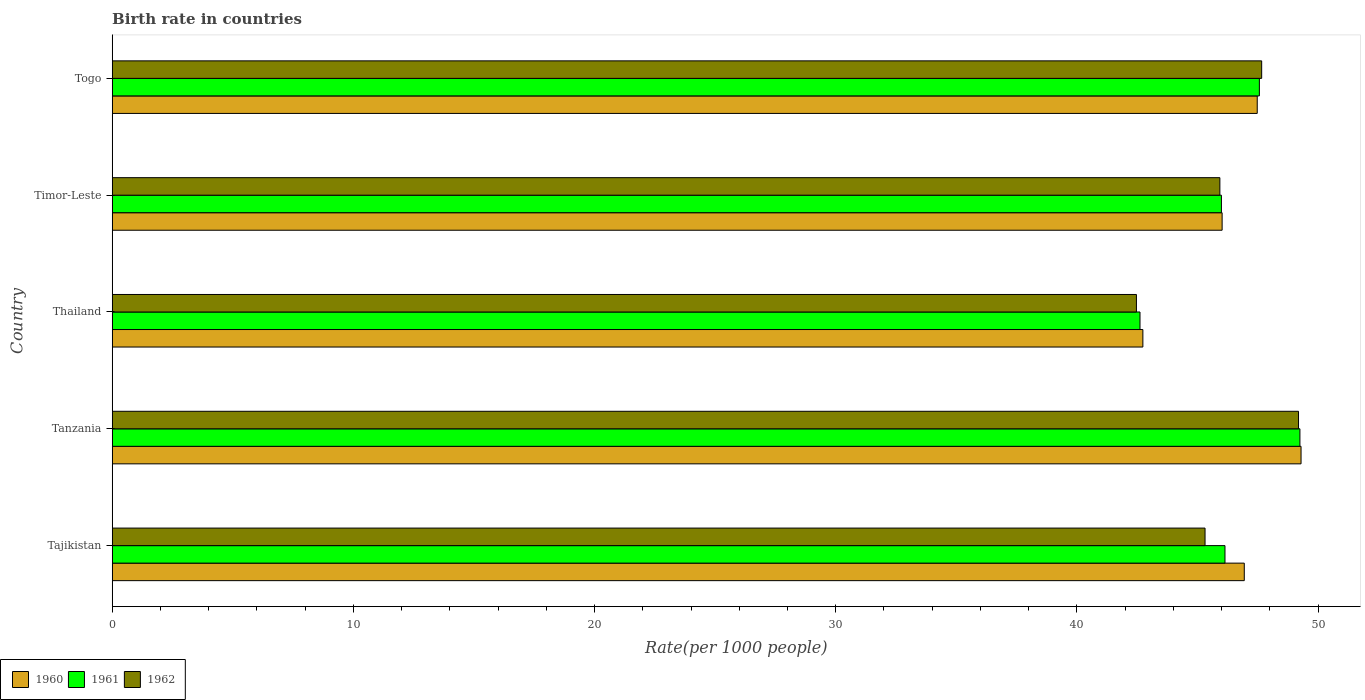How many different coloured bars are there?
Your response must be concise. 3. How many groups of bars are there?
Give a very brief answer. 5. How many bars are there on the 5th tick from the bottom?
Your response must be concise. 3. What is the label of the 1st group of bars from the top?
Offer a terse response. Togo. In how many cases, is the number of bars for a given country not equal to the number of legend labels?
Offer a very short reply. 0. What is the birth rate in 1961 in Timor-Leste?
Offer a very short reply. 45.99. Across all countries, what is the maximum birth rate in 1960?
Provide a succinct answer. 49.3. Across all countries, what is the minimum birth rate in 1961?
Provide a short and direct response. 42.62. In which country was the birth rate in 1961 maximum?
Ensure brevity in your answer.  Tanzania. In which country was the birth rate in 1960 minimum?
Your answer should be very brief. Thailand. What is the total birth rate in 1961 in the graph?
Your response must be concise. 231.57. What is the difference between the birth rate in 1960 in Tajikistan and that in Timor-Leste?
Your response must be concise. 0.92. What is the difference between the birth rate in 1962 in Togo and the birth rate in 1961 in Tanzania?
Offer a very short reply. -1.59. What is the average birth rate in 1961 per country?
Provide a short and direct response. 46.31. What is the difference between the birth rate in 1960 and birth rate in 1961 in Tajikistan?
Your answer should be compact. 0.8. What is the ratio of the birth rate in 1960 in Timor-Leste to that in Togo?
Make the answer very short. 0.97. What is the difference between the highest and the second highest birth rate in 1962?
Provide a short and direct response. 1.53. What is the difference between the highest and the lowest birth rate in 1961?
Your answer should be compact. 6.63. In how many countries, is the birth rate in 1961 greater than the average birth rate in 1961 taken over all countries?
Make the answer very short. 2. Is the sum of the birth rate in 1962 in Tajikistan and Thailand greater than the maximum birth rate in 1960 across all countries?
Ensure brevity in your answer.  Yes. What does the 2nd bar from the bottom in Tajikistan represents?
Your response must be concise. 1961. Is it the case that in every country, the sum of the birth rate in 1962 and birth rate in 1960 is greater than the birth rate in 1961?
Offer a very short reply. Yes. Are all the bars in the graph horizontal?
Offer a very short reply. Yes. How many countries are there in the graph?
Offer a very short reply. 5. Are the values on the major ticks of X-axis written in scientific E-notation?
Your answer should be compact. No. Does the graph contain any zero values?
Give a very brief answer. No. Does the graph contain grids?
Ensure brevity in your answer.  No. Where does the legend appear in the graph?
Ensure brevity in your answer.  Bottom left. What is the title of the graph?
Your response must be concise. Birth rate in countries. Does "1974" appear as one of the legend labels in the graph?
Make the answer very short. No. What is the label or title of the X-axis?
Make the answer very short. Rate(per 1000 people). What is the Rate(per 1000 people) of 1960 in Tajikistan?
Keep it short and to the point. 46.94. What is the Rate(per 1000 people) of 1961 in Tajikistan?
Ensure brevity in your answer.  46.14. What is the Rate(per 1000 people) of 1962 in Tajikistan?
Your answer should be very brief. 45.31. What is the Rate(per 1000 people) of 1960 in Tanzania?
Ensure brevity in your answer.  49.3. What is the Rate(per 1000 people) of 1961 in Tanzania?
Your answer should be very brief. 49.25. What is the Rate(per 1000 people) of 1962 in Tanzania?
Offer a terse response. 49.19. What is the Rate(per 1000 people) in 1960 in Thailand?
Offer a terse response. 42.74. What is the Rate(per 1000 people) in 1961 in Thailand?
Keep it short and to the point. 42.62. What is the Rate(per 1000 people) of 1962 in Thailand?
Your response must be concise. 42.47. What is the Rate(per 1000 people) of 1960 in Timor-Leste?
Your response must be concise. 46.02. What is the Rate(per 1000 people) of 1961 in Timor-Leste?
Your answer should be very brief. 45.99. What is the Rate(per 1000 people) of 1962 in Timor-Leste?
Your answer should be very brief. 45.93. What is the Rate(per 1000 people) in 1960 in Togo?
Offer a very short reply. 47.48. What is the Rate(per 1000 people) in 1961 in Togo?
Your answer should be very brief. 47.57. What is the Rate(per 1000 people) in 1962 in Togo?
Your answer should be compact. 47.66. Across all countries, what is the maximum Rate(per 1000 people) of 1960?
Give a very brief answer. 49.3. Across all countries, what is the maximum Rate(per 1000 people) of 1961?
Keep it short and to the point. 49.25. Across all countries, what is the maximum Rate(per 1000 people) in 1962?
Provide a short and direct response. 49.19. Across all countries, what is the minimum Rate(per 1000 people) in 1960?
Your response must be concise. 42.74. Across all countries, what is the minimum Rate(per 1000 people) in 1961?
Your answer should be compact. 42.62. Across all countries, what is the minimum Rate(per 1000 people) of 1962?
Your answer should be very brief. 42.47. What is the total Rate(per 1000 people) of 1960 in the graph?
Provide a succinct answer. 232.48. What is the total Rate(per 1000 people) in 1961 in the graph?
Your answer should be very brief. 231.57. What is the total Rate(per 1000 people) in 1962 in the graph?
Offer a terse response. 230.57. What is the difference between the Rate(per 1000 people) in 1960 in Tajikistan and that in Tanzania?
Ensure brevity in your answer.  -2.35. What is the difference between the Rate(per 1000 people) in 1961 in Tajikistan and that in Tanzania?
Provide a short and direct response. -3.11. What is the difference between the Rate(per 1000 people) in 1962 in Tajikistan and that in Tanzania?
Offer a very short reply. -3.88. What is the difference between the Rate(per 1000 people) of 1960 in Tajikistan and that in Thailand?
Offer a terse response. 4.21. What is the difference between the Rate(per 1000 people) of 1961 in Tajikistan and that in Thailand?
Ensure brevity in your answer.  3.52. What is the difference between the Rate(per 1000 people) of 1962 in Tajikistan and that in Thailand?
Keep it short and to the point. 2.85. What is the difference between the Rate(per 1000 people) in 1960 in Tajikistan and that in Timor-Leste?
Your answer should be very brief. 0.92. What is the difference between the Rate(per 1000 people) of 1961 in Tajikistan and that in Timor-Leste?
Make the answer very short. 0.15. What is the difference between the Rate(per 1000 people) in 1962 in Tajikistan and that in Timor-Leste?
Provide a succinct answer. -0.61. What is the difference between the Rate(per 1000 people) of 1960 in Tajikistan and that in Togo?
Your response must be concise. -0.54. What is the difference between the Rate(per 1000 people) in 1961 in Tajikistan and that in Togo?
Your answer should be compact. -1.43. What is the difference between the Rate(per 1000 people) of 1962 in Tajikistan and that in Togo?
Provide a short and direct response. -2.35. What is the difference between the Rate(per 1000 people) of 1960 in Tanzania and that in Thailand?
Offer a terse response. 6.56. What is the difference between the Rate(per 1000 people) of 1961 in Tanzania and that in Thailand?
Provide a succinct answer. 6.63. What is the difference between the Rate(per 1000 people) in 1962 in Tanzania and that in Thailand?
Make the answer very short. 6.72. What is the difference between the Rate(per 1000 people) of 1960 in Tanzania and that in Timor-Leste?
Offer a terse response. 3.27. What is the difference between the Rate(per 1000 people) of 1961 in Tanzania and that in Timor-Leste?
Provide a succinct answer. 3.25. What is the difference between the Rate(per 1000 people) in 1962 in Tanzania and that in Timor-Leste?
Offer a terse response. 3.26. What is the difference between the Rate(per 1000 people) in 1960 in Tanzania and that in Togo?
Make the answer very short. 1.82. What is the difference between the Rate(per 1000 people) of 1961 in Tanzania and that in Togo?
Offer a terse response. 1.68. What is the difference between the Rate(per 1000 people) of 1962 in Tanzania and that in Togo?
Your response must be concise. 1.53. What is the difference between the Rate(per 1000 people) of 1960 in Thailand and that in Timor-Leste?
Provide a short and direct response. -3.29. What is the difference between the Rate(per 1000 people) in 1961 in Thailand and that in Timor-Leste?
Provide a short and direct response. -3.38. What is the difference between the Rate(per 1000 people) in 1962 in Thailand and that in Timor-Leste?
Your response must be concise. -3.46. What is the difference between the Rate(per 1000 people) in 1960 in Thailand and that in Togo?
Provide a short and direct response. -4.74. What is the difference between the Rate(per 1000 people) of 1961 in Thailand and that in Togo?
Your response must be concise. -4.95. What is the difference between the Rate(per 1000 people) of 1962 in Thailand and that in Togo?
Provide a short and direct response. -5.19. What is the difference between the Rate(per 1000 people) in 1960 in Timor-Leste and that in Togo?
Provide a short and direct response. -1.46. What is the difference between the Rate(per 1000 people) in 1961 in Timor-Leste and that in Togo?
Make the answer very short. -1.57. What is the difference between the Rate(per 1000 people) in 1962 in Timor-Leste and that in Togo?
Make the answer very short. -1.73. What is the difference between the Rate(per 1000 people) in 1960 in Tajikistan and the Rate(per 1000 people) in 1961 in Tanzania?
Give a very brief answer. -2.31. What is the difference between the Rate(per 1000 people) of 1960 in Tajikistan and the Rate(per 1000 people) of 1962 in Tanzania?
Ensure brevity in your answer.  -2.25. What is the difference between the Rate(per 1000 people) of 1961 in Tajikistan and the Rate(per 1000 people) of 1962 in Tanzania?
Keep it short and to the point. -3.05. What is the difference between the Rate(per 1000 people) in 1960 in Tajikistan and the Rate(per 1000 people) in 1961 in Thailand?
Make the answer very short. 4.32. What is the difference between the Rate(per 1000 people) of 1960 in Tajikistan and the Rate(per 1000 people) of 1962 in Thailand?
Keep it short and to the point. 4.47. What is the difference between the Rate(per 1000 people) in 1961 in Tajikistan and the Rate(per 1000 people) in 1962 in Thailand?
Your answer should be very brief. 3.67. What is the difference between the Rate(per 1000 people) of 1960 in Tajikistan and the Rate(per 1000 people) of 1961 in Timor-Leste?
Give a very brief answer. 0.95. What is the difference between the Rate(per 1000 people) of 1961 in Tajikistan and the Rate(per 1000 people) of 1962 in Timor-Leste?
Your answer should be very brief. 0.21. What is the difference between the Rate(per 1000 people) of 1960 in Tajikistan and the Rate(per 1000 people) of 1961 in Togo?
Make the answer very short. -0.63. What is the difference between the Rate(per 1000 people) in 1960 in Tajikistan and the Rate(per 1000 people) in 1962 in Togo?
Your answer should be very brief. -0.72. What is the difference between the Rate(per 1000 people) of 1961 in Tajikistan and the Rate(per 1000 people) of 1962 in Togo?
Give a very brief answer. -1.52. What is the difference between the Rate(per 1000 people) of 1960 in Tanzania and the Rate(per 1000 people) of 1961 in Thailand?
Give a very brief answer. 6.68. What is the difference between the Rate(per 1000 people) of 1960 in Tanzania and the Rate(per 1000 people) of 1962 in Thailand?
Give a very brief answer. 6.83. What is the difference between the Rate(per 1000 people) of 1961 in Tanzania and the Rate(per 1000 people) of 1962 in Thailand?
Offer a very short reply. 6.78. What is the difference between the Rate(per 1000 people) in 1960 in Tanzania and the Rate(per 1000 people) in 1961 in Timor-Leste?
Provide a succinct answer. 3.3. What is the difference between the Rate(per 1000 people) in 1960 in Tanzania and the Rate(per 1000 people) in 1962 in Timor-Leste?
Make the answer very short. 3.37. What is the difference between the Rate(per 1000 people) of 1961 in Tanzania and the Rate(per 1000 people) of 1962 in Timor-Leste?
Your answer should be very brief. 3.32. What is the difference between the Rate(per 1000 people) of 1960 in Tanzania and the Rate(per 1000 people) of 1961 in Togo?
Your response must be concise. 1.73. What is the difference between the Rate(per 1000 people) of 1960 in Tanzania and the Rate(per 1000 people) of 1962 in Togo?
Provide a short and direct response. 1.63. What is the difference between the Rate(per 1000 people) in 1961 in Tanzania and the Rate(per 1000 people) in 1962 in Togo?
Keep it short and to the point. 1.59. What is the difference between the Rate(per 1000 people) of 1960 in Thailand and the Rate(per 1000 people) of 1961 in Timor-Leste?
Provide a short and direct response. -3.26. What is the difference between the Rate(per 1000 people) of 1960 in Thailand and the Rate(per 1000 people) of 1962 in Timor-Leste?
Keep it short and to the point. -3.19. What is the difference between the Rate(per 1000 people) in 1961 in Thailand and the Rate(per 1000 people) in 1962 in Timor-Leste?
Provide a succinct answer. -3.31. What is the difference between the Rate(per 1000 people) of 1960 in Thailand and the Rate(per 1000 people) of 1961 in Togo?
Ensure brevity in your answer.  -4.83. What is the difference between the Rate(per 1000 people) in 1960 in Thailand and the Rate(per 1000 people) in 1962 in Togo?
Give a very brief answer. -4.93. What is the difference between the Rate(per 1000 people) of 1961 in Thailand and the Rate(per 1000 people) of 1962 in Togo?
Provide a short and direct response. -5.04. What is the difference between the Rate(per 1000 people) in 1960 in Timor-Leste and the Rate(per 1000 people) in 1961 in Togo?
Offer a terse response. -1.54. What is the difference between the Rate(per 1000 people) of 1960 in Timor-Leste and the Rate(per 1000 people) of 1962 in Togo?
Ensure brevity in your answer.  -1.64. What is the difference between the Rate(per 1000 people) in 1961 in Timor-Leste and the Rate(per 1000 people) in 1962 in Togo?
Your answer should be very brief. -1.67. What is the average Rate(per 1000 people) in 1960 per country?
Make the answer very short. 46.5. What is the average Rate(per 1000 people) in 1961 per country?
Keep it short and to the point. 46.31. What is the average Rate(per 1000 people) of 1962 per country?
Your answer should be compact. 46.11. What is the difference between the Rate(per 1000 people) of 1960 and Rate(per 1000 people) of 1962 in Tajikistan?
Provide a short and direct response. 1.63. What is the difference between the Rate(per 1000 people) of 1961 and Rate(per 1000 people) of 1962 in Tajikistan?
Provide a succinct answer. 0.83. What is the difference between the Rate(per 1000 people) of 1960 and Rate(per 1000 people) of 1961 in Tanzania?
Provide a short and direct response. 0.05. What is the difference between the Rate(per 1000 people) in 1960 and Rate(per 1000 people) in 1962 in Tanzania?
Offer a very short reply. 0.1. What is the difference between the Rate(per 1000 people) of 1961 and Rate(per 1000 people) of 1962 in Tanzania?
Offer a very short reply. 0.06. What is the difference between the Rate(per 1000 people) of 1960 and Rate(per 1000 people) of 1961 in Thailand?
Offer a terse response. 0.12. What is the difference between the Rate(per 1000 people) of 1960 and Rate(per 1000 people) of 1962 in Thailand?
Offer a terse response. 0.27. What is the difference between the Rate(per 1000 people) of 1961 and Rate(per 1000 people) of 1962 in Thailand?
Ensure brevity in your answer.  0.15. What is the difference between the Rate(per 1000 people) in 1960 and Rate(per 1000 people) in 1961 in Timor-Leste?
Make the answer very short. 0.03. What is the difference between the Rate(per 1000 people) in 1960 and Rate(per 1000 people) in 1962 in Timor-Leste?
Provide a short and direct response. 0.09. What is the difference between the Rate(per 1000 people) in 1961 and Rate(per 1000 people) in 1962 in Timor-Leste?
Your answer should be compact. 0.06. What is the difference between the Rate(per 1000 people) in 1960 and Rate(per 1000 people) in 1961 in Togo?
Make the answer very short. -0.09. What is the difference between the Rate(per 1000 people) of 1960 and Rate(per 1000 people) of 1962 in Togo?
Your answer should be compact. -0.18. What is the difference between the Rate(per 1000 people) of 1961 and Rate(per 1000 people) of 1962 in Togo?
Make the answer very short. -0.1. What is the ratio of the Rate(per 1000 people) of 1960 in Tajikistan to that in Tanzania?
Provide a short and direct response. 0.95. What is the ratio of the Rate(per 1000 people) in 1961 in Tajikistan to that in Tanzania?
Your response must be concise. 0.94. What is the ratio of the Rate(per 1000 people) in 1962 in Tajikistan to that in Tanzania?
Provide a succinct answer. 0.92. What is the ratio of the Rate(per 1000 people) of 1960 in Tajikistan to that in Thailand?
Your response must be concise. 1.1. What is the ratio of the Rate(per 1000 people) in 1961 in Tajikistan to that in Thailand?
Provide a succinct answer. 1.08. What is the ratio of the Rate(per 1000 people) of 1962 in Tajikistan to that in Thailand?
Offer a terse response. 1.07. What is the ratio of the Rate(per 1000 people) of 1960 in Tajikistan to that in Timor-Leste?
Keep it short and to the point. 1.02. What is the ratio of the Rate(per 1000 people) in 1962 in Tajikistan to that in Timor-Leste?
Offer a terse response. 0.99. What is the ratio of the Rate(per 1000 people) in 1960 in Tajikistan to that in Togo?
Offer a very short reply. 0.99. What is the ratio of the Rate(per 1000 people) of 1961 in Tajikistan to that in Togo?
Make the answer very short. 0.97. What is the ratio of the Rate(per 1000 people) in 1962 in Tajikistan to that in Togo?
Your response must be concise. 0.95. What is the ratio of the Rate(per 1000 people) in 1960 in Tanzania to that in Thailand?
Give a very brief answer. 1.15. What is the ratio of the Rate(per 1000 people) of 1961 in Tanzania to that in Thailand?
Provide a succinct answer. 1.16. What is the ratio of the Rate(per 1000 people) in 1962 in Tanzania to that in Thailand?
Your response must be concise. 1.16. What is the ratio of the Rate(per 1000 people) of 1960 in Tanzania to that in Timor-Leste?
Provide a short and direct response. 1.07. What is the ratio of the Rate(per 1000 people) of 1961 in Tanzania to that in Timor-Leste?
Provide a succinct answer. 1.07. What is the ratio of the Rate(per 1000 people) of 1962 in Tanzania to that in Timor-Leste?
Your answer should be very brief. 1.07. What is the ratio of the Rate(per 1000 people) in 1960 in Tanzania to that in Togo?
Ensure brevity in your answer.  1.04. What is the ratio of the Rate(per 1000 people) of 1961 in Tanzania to that in Togo?
Ensure brevity in your answer.  1.04. What is the ratio of the Rate(per 1000 people) in 1962 in Tanzania to that in Togo?
Your answer should be very brief. 1.03. What is the ratio of the Rate(per 1000 people) in 1960 in Thailand to that in Timor-Leste?
Keep it short and to the point. 0.93. What is the ratio of the Rate(per 1000 people) in 1961 in Thailand to that in Timor-Leste?
Provide a short and direct response. 0.93. What is the ratio of the Rate(per 1000 people) in 1962 in Thailand to that in Timor-Leste?
Your response must be concise. 0.92. What is the ratio of the Rate(per 1000 people) in 1960 in Thailand to that in Togo?
Offer a terse response. 0.9. What is the ratio of the Rate(per 1000 people) of 1961 in Thailand to that in Togo?
Give a very brief answer. 0.9. What is the ratio of the Rate(per 1000 people) of 1962 in Thailand to that in Togo?
Ensure brevity in your answer.  0.89. What is the ratio of the Rate(per 1000 people) in 1960 in Timor-Leste to that in Togo?
Keep it short and to the point. 0.97. What is the ratio of the Rate(per 1000 people) of 1961 in Timor-Leste to that in Togo?
Your response must be concise. 0.97. What is the ratio of the Rate(per 1000 people) in 1962 in Timor-Leste to that in Togo?
Ensure brevity in your answer.  0.96. What is the difference between the highest and the second highest Rate(per 1000 people) of 1960?
Give a very brief answer. 1.82. What is the difference between the highest and the second highest Rate(per 1000 people) of 1961?
Your answer should be very brief. 1.68. What is the difference between the highest and the second highest Rate(per 1000 people) in 1962?
Offer a very short reply. 1.53. What is the difference between the highest and the lowest Rate(per 1000 people) in 1960?
Provide a succinct answer. 6.56. What is the difference between the highest and the lowest Rate(per 1000 people) of 1961?
Offer a very short reply. 6.63. What is the difference between the highest and the lowest Rate(per 1000 people) in 1962?
Your response must be concise. 6.72. 